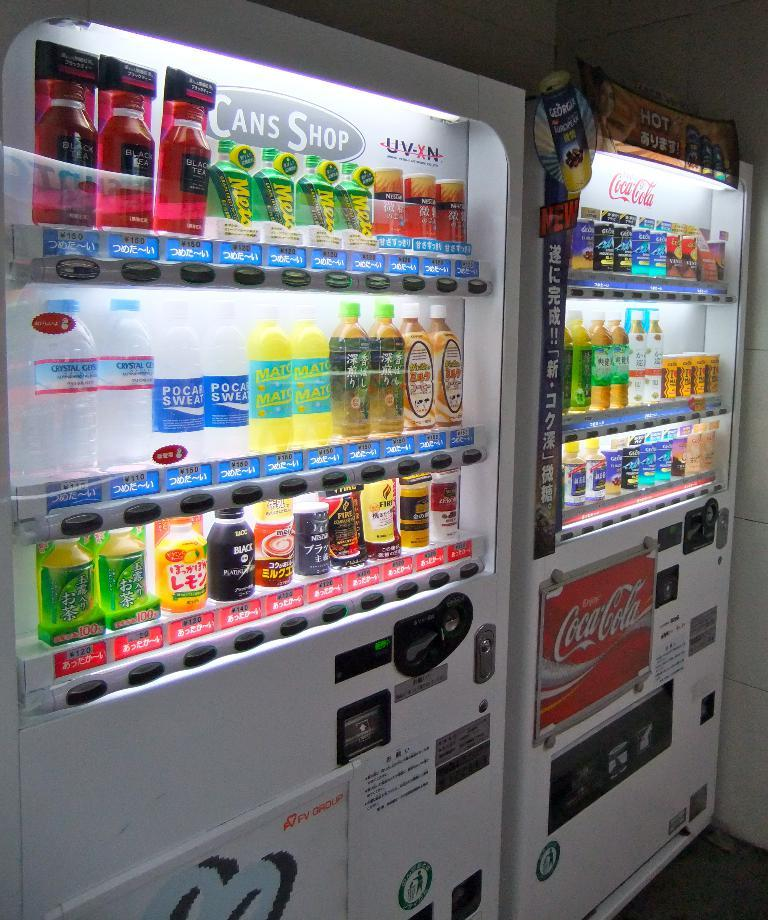What type of appliances can be seen in the image? There are refrigerators in the image. What are the refrigerators holding? Beverages are placed inside the refrigerators. What can be seen in the background of the image? There is a wall in the background of the image. What type of drug is being sold near the refrigerators in the image? There is no indication of any drug being sold or present in the image. 